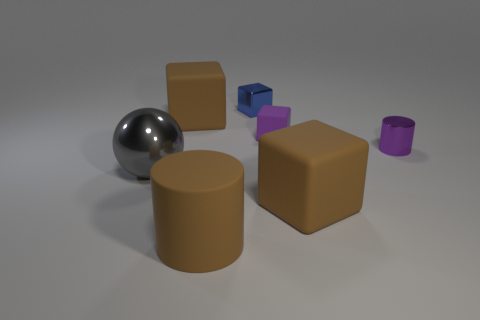Subtract all brown cubes. How many were subtracted if there are1brown cubes left? 1 Subtract all blue metal cubes. How many cubes are left? 3 Subtract all blue blocks. How many blocks are left? 3 Subtract 1 cylinders. How many cylinders are left? 1 Subtract all blocks. How many objects are left? 3 Add 1 tiny purple cylinders. How many objects exist? 8 Subtract all purple balls. How many purple cylinders are left? 1 Subtract all large blue matte things. Subtract all tiny purple shiny cylinders. How many objects are left? 6 Add 2 tiny purple blocks. How many tiny purple blocks are left? 3 Add 4 tiny shiny things. How many tiny shiny things exist? 6 